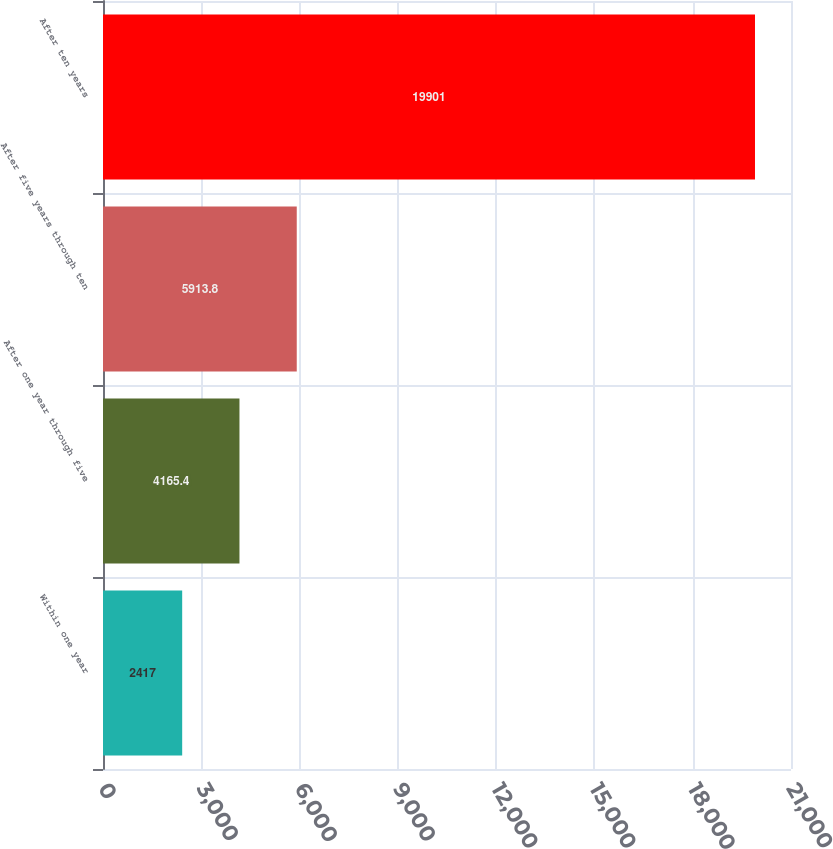Convert chart to OTSL. <chart><loc_0><loc_0><loc_500><loc_500><bar_chart><fcel>Within one year<fcel>After one year through five<fcel>After five years through ten<fcel>After ten years<nl><fcel>2417<fcel>4165.4<fcel>5913.8<fcel>19901<nl></chart> 